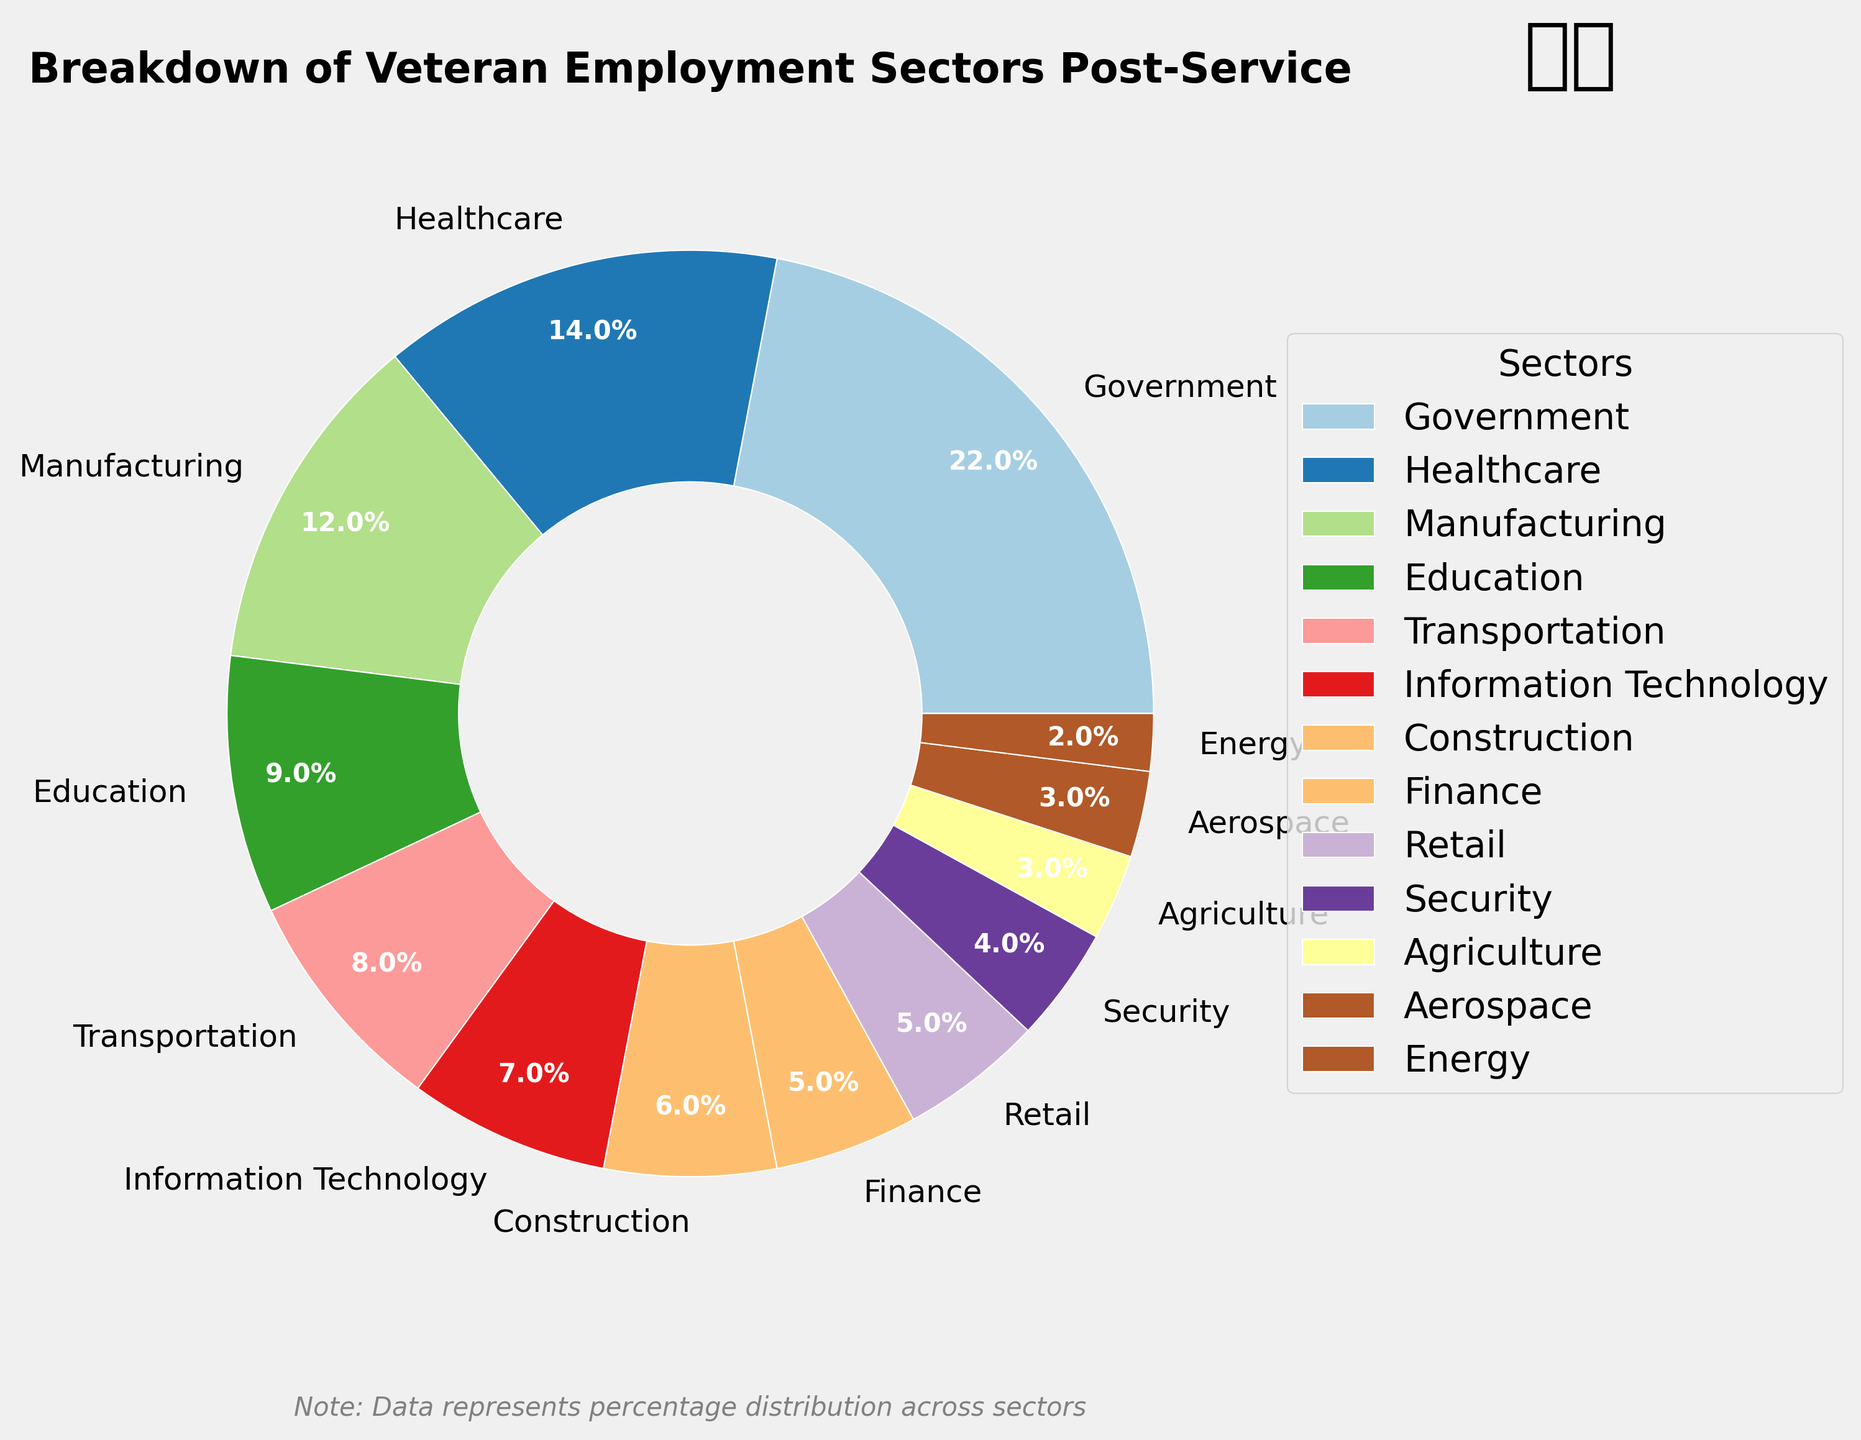What is the largest employment sector for veterans post-service? The largest sector can be identified by looking at the segment with the biggest area. The Government sector occupies the largest portion of the pie chart.
Answer: Government What is the combined percentage of veterans working in Healthcare and Manufacturing sectors? Add the percentages of the Healthcare sector (14%) and the Manufacturing sector (12%). 14 + 12 = 26.
Answer: 26% Which sector employs fewer veterans: Construction or Education? Compare the percentages of the Construction sector (6%) and the Education sector (9%). Construction has a lower percentage than Education.
Answer: Construction What is the total percentage of veterans working in sectors with less than 5% representation each? Add the percentages of the sectors with less than 5% each: Security (4%), Agriculture (3%), Aerospace (3%), and Energy (2%). 4 + 3 + 3 + 2 = 12.
Answer: 12% Among the listed sectors, which one has the same percentage of veteran employment as Retail? Look for another sector that has the same percentage as Retail (5%). The Finance sector also has 5%.
Answer: Finance What is the difference in veteran employment percentages between the highest and the lowest sectors? Subtract the percentage of the lowest sector (Energy, 2%) from the highest sector (Government, 22%). 22 - 2 = 20.
Answer: 20% What is the combined percentage of veterans working in sectors related to transportation (i.e., Transportation and Aerospace)? Add the percentages of the Transportation (8%) and Aerospace (3%) sectors. 8 + 3 = 11.
Answer: 11% Which sector has a higher employment percentage, Information Technology or Security? Compare the percentages of Information Technology (7%) and Security (4%). Information Technology has a higher percentage.
Answer: Information Technology How many sectors employ more than 10% of veterans? Identify sectors with percentages more than 10%: Government (22%), Healthcare (14%), and Manufacturing (12%). There are 3 such sectors.
Answer: 3 What is the average percentage of veterans working in sectors with more than 5% representation? Identify sectors above 5% and calculate the average: Government (22%), Healthcare (14%), Manufacturing (12%), Education (9%), Transportation (8%), and Information Technology (7%). Sum these percentages: 22 + 14 + 12 + 9 + 8 + 7 = 72. There are 6 sectors, so the average is 72/6 = 12.
Answer: 12% 